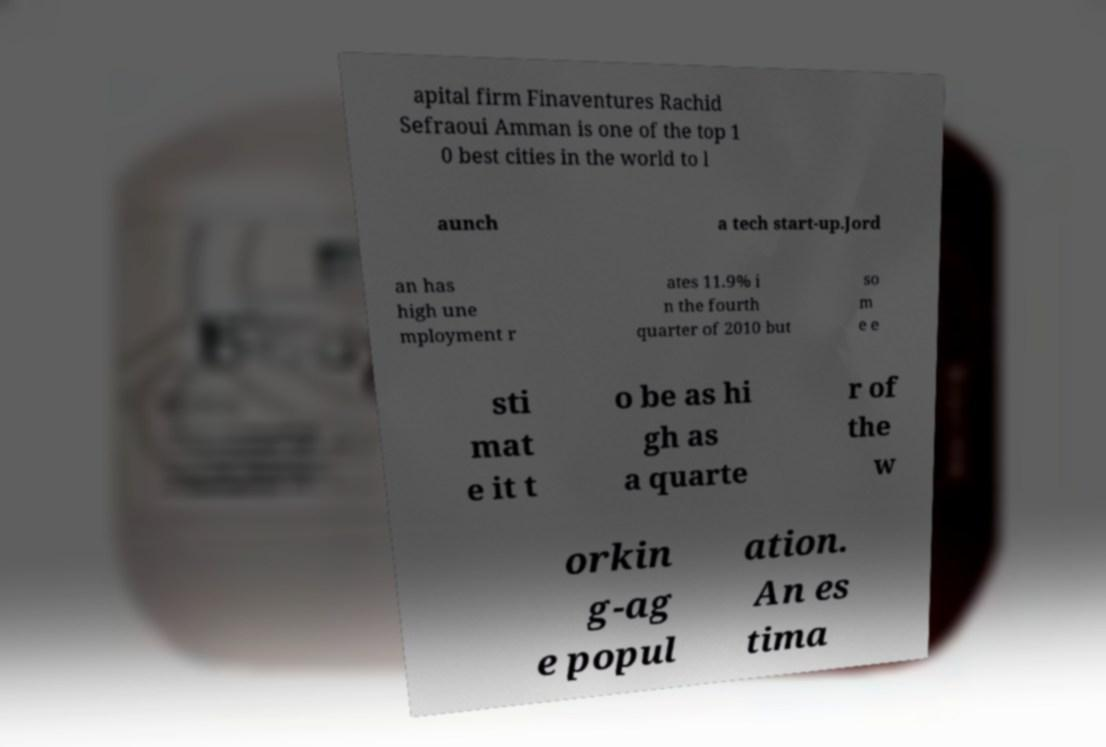Please read and relay the text visible in this image. What does it say? apital firm Finaventures Rachid Sefraoui Amman is one of the top 1 0 best cities in the world to l aunch a tech start-up.Jord an has high une mployment r ates 11.9% i n the fourth quarter of 2010 but so m e e sti mat e it t o be as hi gh as a quarte r of the w orkin g-ag e popul ation. An es tima 